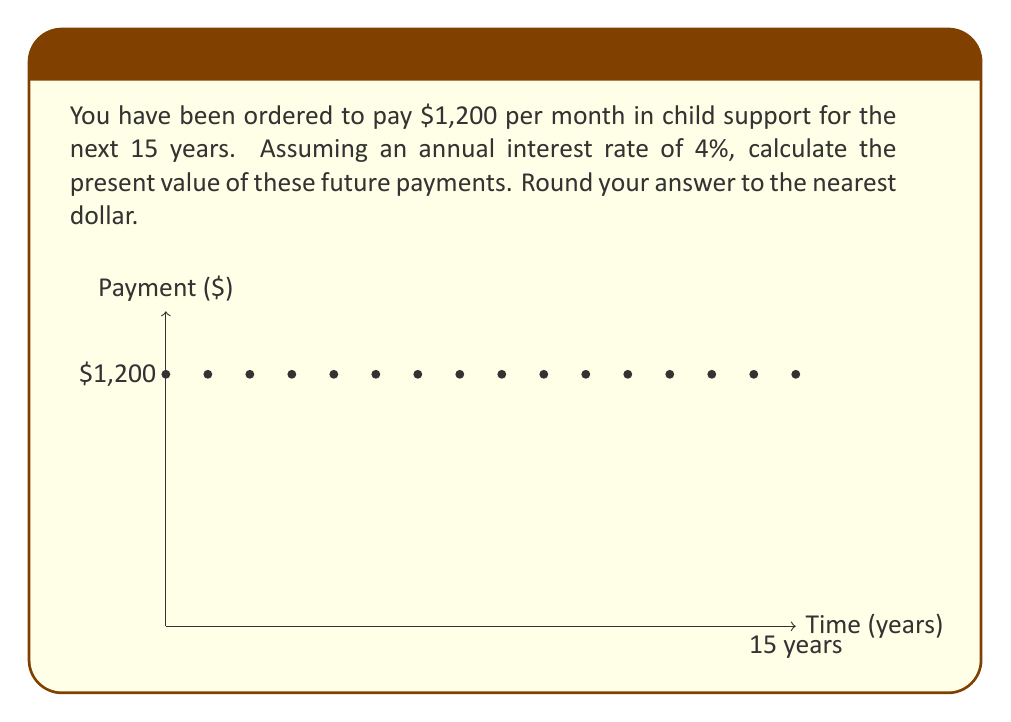Could you help me with this problem? To calculate the present value of future payments, we need to use the present value of an annuity formula:

$$ PV = PMT \times \frac{1 - (1 + r)^{-n}}{r} $$

Where:
- $PV$ is the present value
- $PMT$ is the periodic payment amount
- $r$ is the periodic interest rate
- $n$ is the number of periods

Given:
- $PMT = \$1,200$ per month
- $n = 15 \times 12 = 180$ months (15 years)
- Annual interest rate = 4%

Step 1: Convert the annual interest rate to a monthly rate:
$$ r = \frac{4\%}{12} = 0.0033333 $$

Step 2: Apply the formula:

$$ PV = 1200 \times \frac{1 - (1 + 0.0033333)^{-180}}{0.0033333} $$

Step 3: Calculate using a financial calculator or spreadsheet function:

$$ PV = 1200 \times 139.5784 = 167,494.08 $$

Step 4: Round to the nearest dollar:

$$ PV \approx \$167,494 $$
Answer: $167,494 